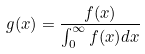Convert formula to latex. <formula><loc_0><loc_0><loc_500><loc_500>g ( x ) = \frac { f ( x ) } { \int _ { 0 } ^ { \infty } f ( x ) d x }</formula> 